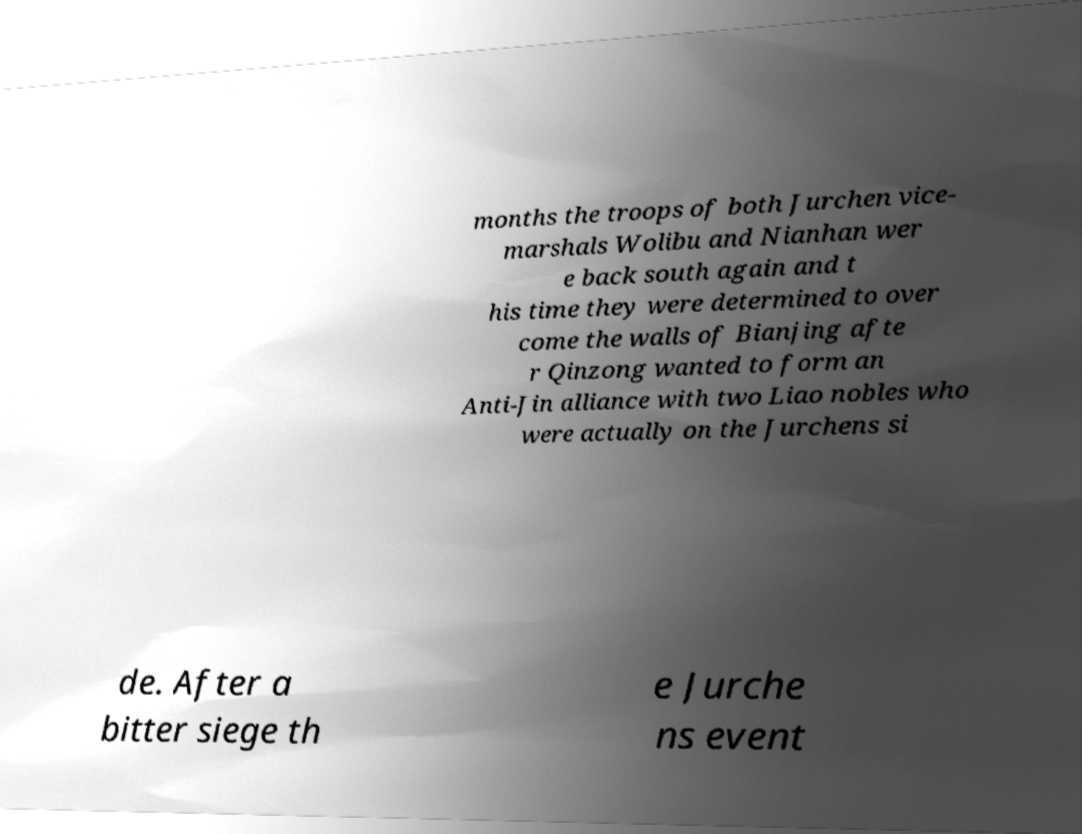Please read and relay the text visible in this image. What does it say? months the troops of both Jurchen vice- marshals Wolibu and Nianhan wer e back south again and t his time they were determined to over come the walls of Bianjing afte r Qinzong wanted to form an Anti-Jin alliance with two Liao nobles who were actually on the Jurchens si de. After a bitter siege th e Jurche ns event 